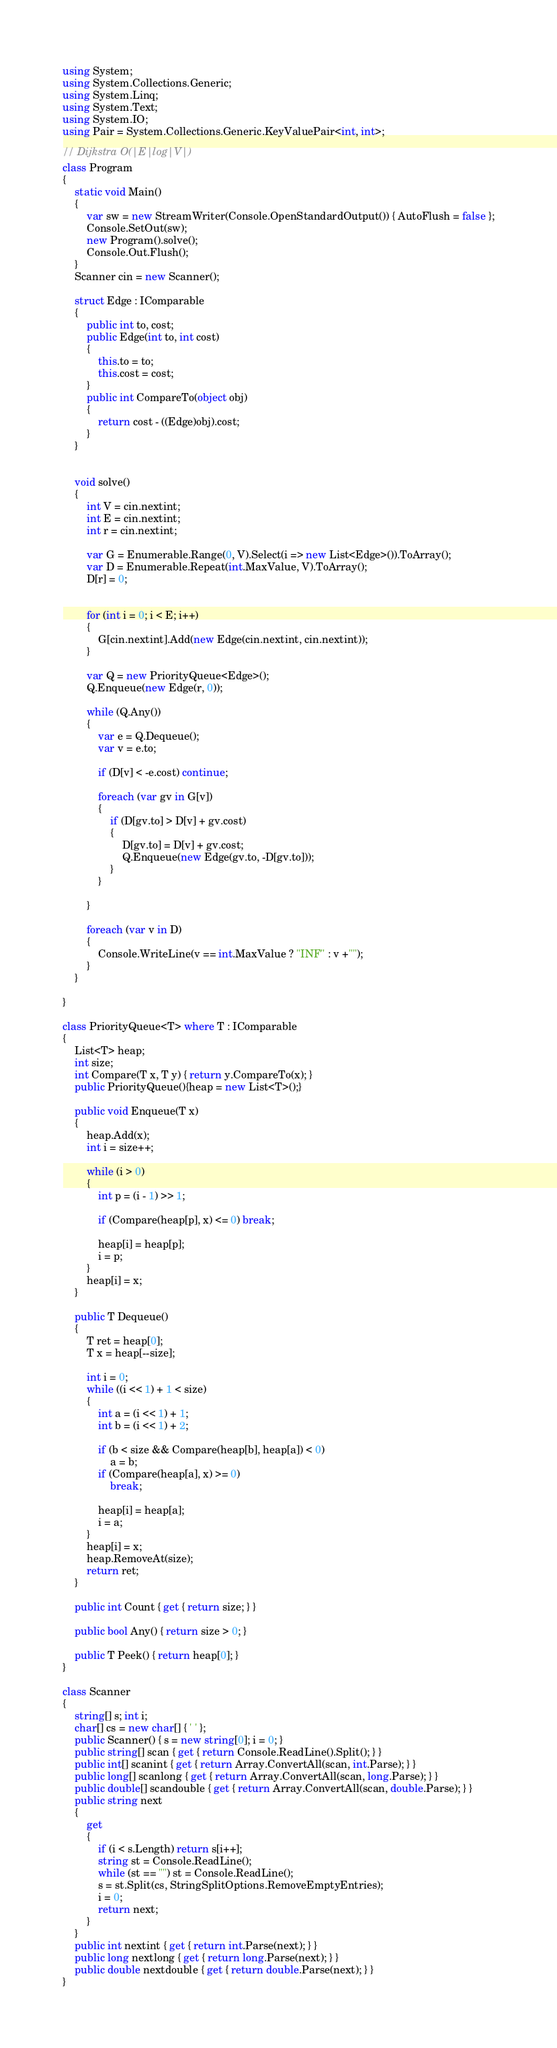<code> <loc_0><loc_0><loc_500><loc_500><_C#_>using System;
using System.Collections.Generic;
using System.Linq;
using System.Text;
using System.IO;
using Pair = System.Collections.Generic.KeyValuePair<int, int>;

// Dijkstra O(|E|log|V|)
class Program
{
    static void Main()
    {
        var sw = new StreamWriter(Console.OpenStandardOutput()) { AutoFlush = false };
        Console.SetOut(sw);
        new Program().solve();
        Console.Out.Flush();
    }
    Scanner cin = new Scanner();

    struct Edge : IComparable
    {
        public int to, cost;
        public Edge(int to, int cost)
        {
            this.to = to;
            this.cost = cost;
        }
        public int CompareTo(object obj)
        {
            return cost - ((Edge)obj).cost;
        }
    }


    void solve()
    {
        int V = cin.nextint;
        int E = cin.nextint;
        int r = cin.nextint;

        var G = Enumerable.Range(0, V).Select(i => new List<Edge>()).ToArray();
        var D = Enumerable.Repeat(int.MaxValue, V).ToArray();
        D[r] = 0;


        for (int i = 0; i < E; i++)
        {
            G[cin.nextint].Add(new Edge(cin.nextint, cin.nextint));
        }

        var Q = new PriorityQueue<Edge>();
        Q.Enqueue(new Edge(r, 0));

        while (Q.Any())
        {
            var e = Q.Dequeue();
            var v = e.to;

            if (D[v] < -e.cost) continue;

            foreach (var gv in G[v])
            {
                if (D[gv.to] > D[v] + gv.cost)
                {
                    D[gv.to] = D[v] + gv.cost;
                    Q.Enqueue(new Edge(gv.to, -D[gv.to]));
                }
            }

        }

        foreach (var v in D)
        {
            Console.WriteLine(v == int.MaxValue ? "INF" : v +"");
        }
    }

}

class PriorityQueue<T> where T : IComparable
{
    List<T> heap;
    int size;
    int Compare(T x, T y) { return y.CompareTo(x); }
    public PriorityQueue(){heap = new List<T>();}

    public void Enqueue(T x)
    {
        heap.Add(x);
        int i = size++;

        while (i > 0)
        {
            int p = (i - 1) >> 1;

            if (Compare(heap[p], x) <= 0) break;

            heap[i] = heap[p];
            i = p;
        }
        heap[i] = x;
    }

    public T Dequeue()
    {
        T ret = heap[0];
        T x = heap[--size];

        int i = 0;
        while ((i << 1) + 1 < size)
        {
            int a = (i << 1) + 1;
            int b = (i << 1) + 2;

            if (b < size && Compare(heap[b], heap[a]) < 0)
                a = b;
            if (Compare(heap[a], x) >= 0)
                break;

            heap[i] = heap[a];
            i = a;
        }
        heap[i] = x;
        heap.RemoveAt(size);
        return ret;
    }

    public int Count { get { return size; } }

    public bool Any() { return size > 0; }

    public T Peek() { return heap[0]; }
}

class Scanner
{
    string[] s; int i;
    char[] cs = new char[] { ' ' };
    public Scanner() { s = new string[0]; i = 0; }
    public string[] scan { get { return Console.ReadLine().Split(); } }
    public int[] scanint { get { return Array.ConvertAll(scan, int.Parse); } }
    public long[] scanlong { get { return Array.ConvertAll(scan, long.Parse); } }
    public double[] scandouble { get { return Array.ConvertAll(scan, double.Parse); } }
    public string next
    {
        get
        {
            if (i < s.Length) return s[i++];
            string st = Console.ReadLine();
            while (st == "") st = Console.ReadLine();
            s = st.Split(cs, StringSplitOptions.RemoveEmptyEntries);
            i = 0;
            return next;
        }
    }
    public int nextint { get { return int.Parse(next); } }
    public long nextlong { get { return long.Parse(next); } }
    public double nextdouble { get { return double.Parse(next); } }
}</code> 